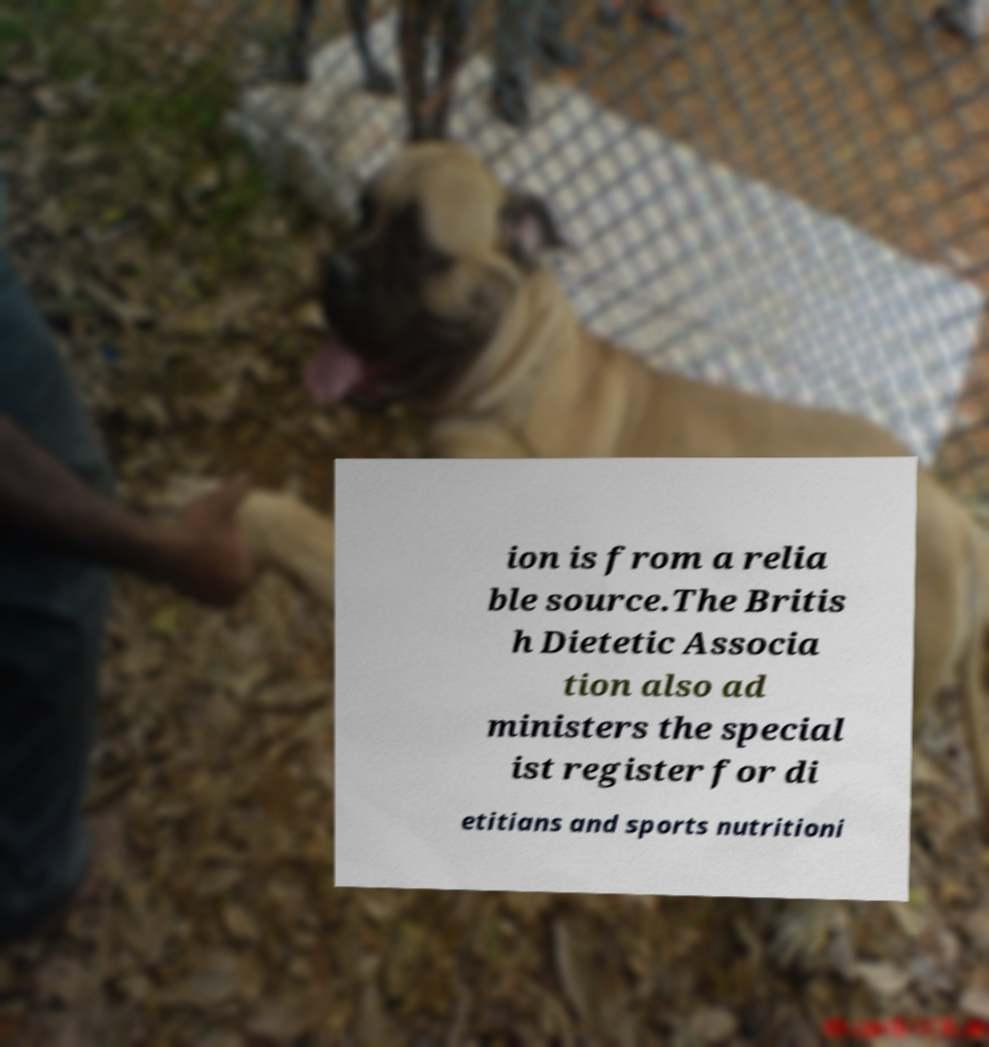Could you assist in decoding the text presented in this image and type it out clearly? ion is from a relia ble source.The Britis h Dietetic Associa tion also ad ministers the special ist register for di etitians and sports nutritioni 